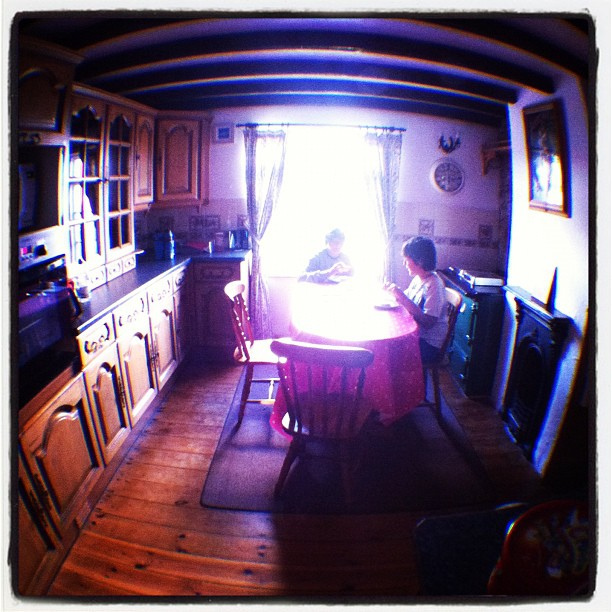What activities might the two individuals at the table be engaged in? The individuals appear to be involved in a casual activity, possibly enjoying a meal together or engaged in a relaxed conversation, as indicated by the laid-back posture and the presence of some items on the table which could be food or drink containers. 